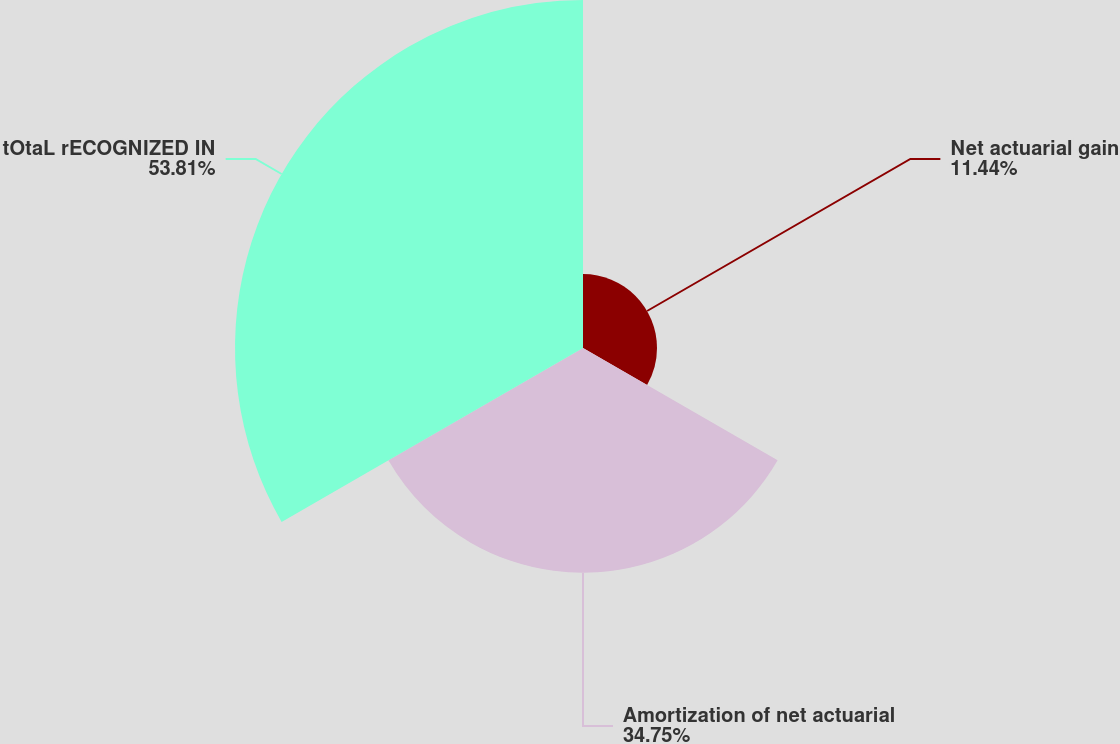Convert chart to OTSL. <chart><loc_0><loc_0><loc_500><loc_500><pie_chart><fcel>Net actuarial gain<fcel>Amortization of net actuarial<fcel>tOtaL rECOGNIZED IN<nl><fcel>11.44%<fcel>34.75%<fcel>53.81%<nl></chart> 